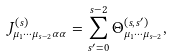Convert formula to latex. <formula><loc_0><loc_0><loc_500><loc_500>J _ { \mu _ { 1 } \cdots \mu _ { s - 2 } \alpha \alpha } ^ { ( s ) } = \sum _ { s ^ { \prime } = 0 } ^ { s - 2 } \Theta _ { \mu _ { 1 } \cdots \mu _ { s - 2 } } ^ { ( s , s ^ { \prime } ) } ,</formula> 